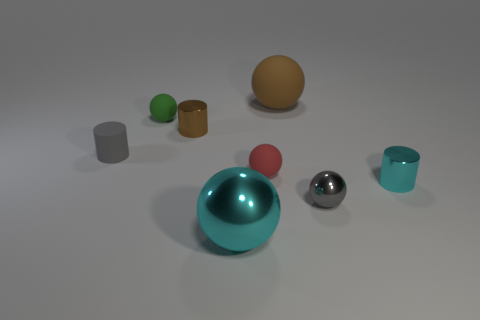Subtract all small metallic cylinders. How many cylinders are left? 1 Subtract all red spheres. How many spheres are left? 4 Subtract 1 cylinders. How many cylinders are left? 2 Subtract all cylinders. How many objects are left? 5 Subtract all red spheres. Subtract all blue cubes. How many spheres are left? 4 Add 1 tiny spheres. How many objects exist? 9 Subtract 0 red cylinders. How many objects are left? 8 Subtract all brown spheres. How many brown cylinders are left? 1 Subtract all big gray spheres. Subtract all gray rubber cylinders. How many objects are left? 7 Add 2 balls. How many balls are left? 7 